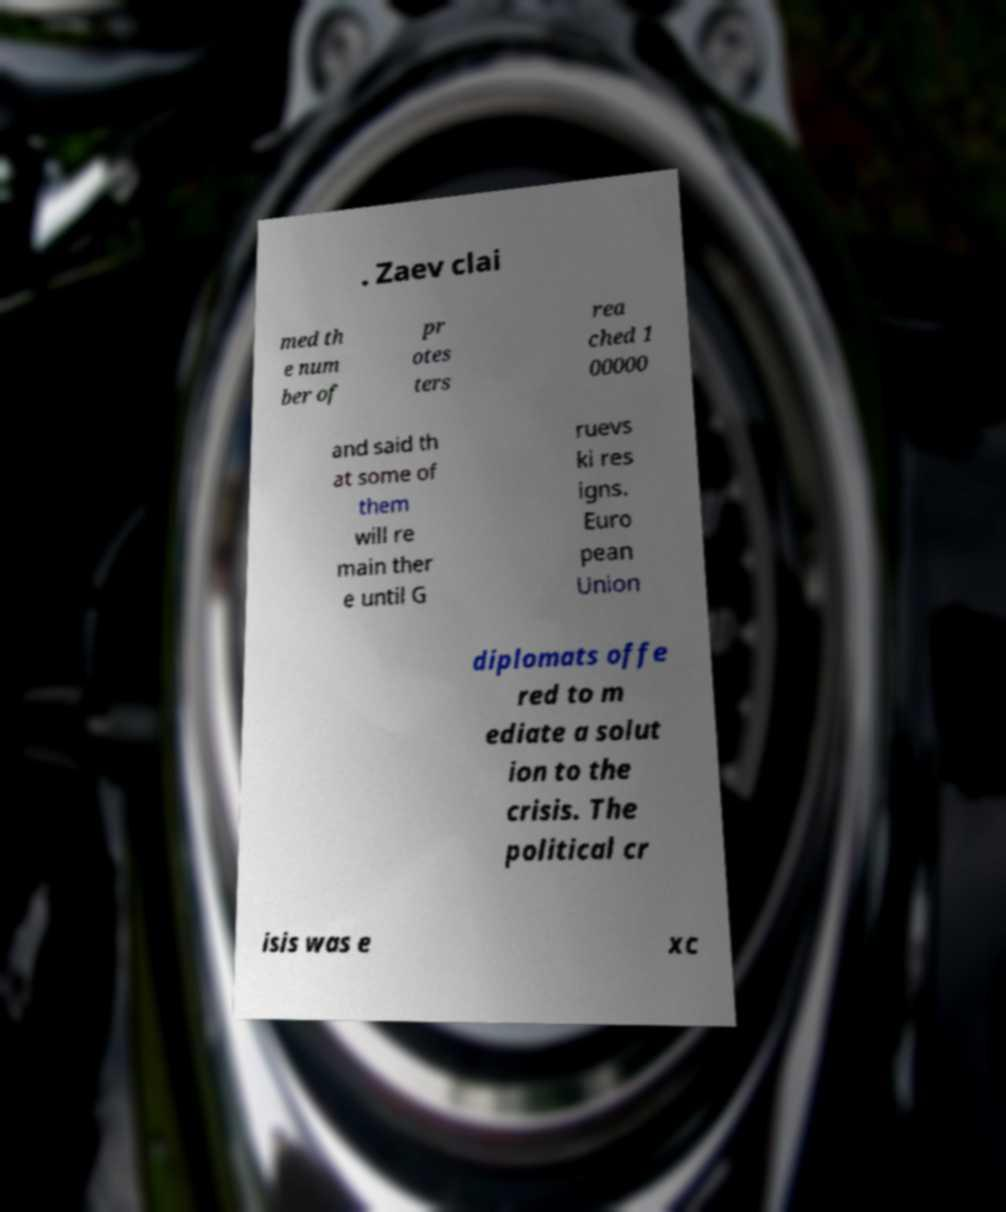Can you read and provide the text displayed in the image?This photo seems to have some interesting text. Can you extract and type it out for me? . Zaev clai med th e num ber of pr otes ters rea ched 1 00000 and said th at some of them will re main ther e until G ruevs ki res igns. Euro pean Union diplomats offe red to m ediate a solut ion to the crisis. The political cr isis was e xc 